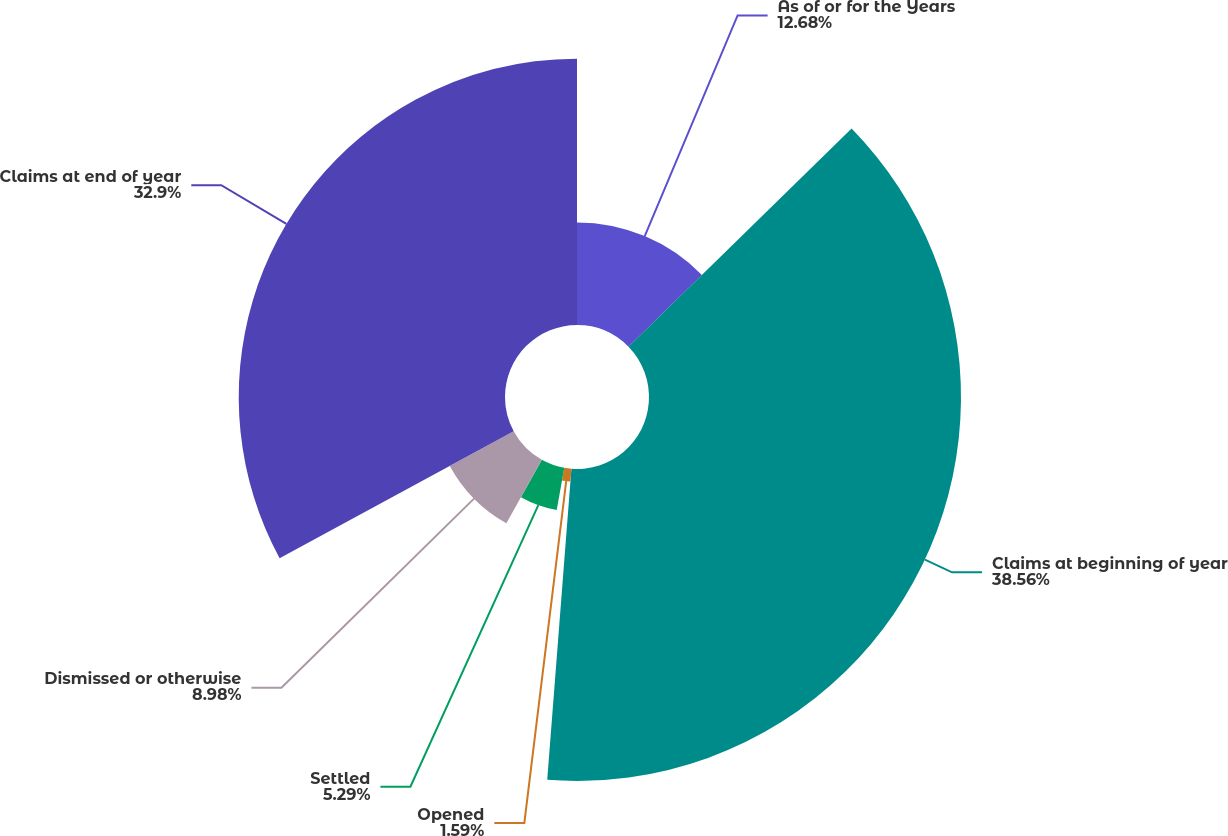Convert chart. <chart><loc_0><loc_0><loc_500><loc_500><pie_chart><fcel>As of or for the Years<fcel>Claims at beginning of year<fcel>Opened<fcel>Settled<fcel>Dismissed or otherwise<fcel>Claims at end of year<nl><fcel>12.68%<fcel>38.55%<fcel>1.59%<fcel>5.29%<fcel>8.98%<fcel>32.9%<nl></chart> 